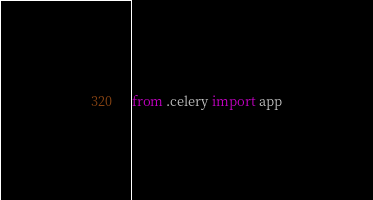Convert code to text. <code><loc_0><loc_0><loc_500><loc_500><_Python_>from .celery import app</code> 